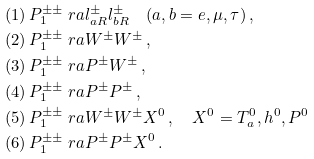<formula> <loc_0><loc_0><loc_500><loc_500>( 1 ) \, P _ { 1 } ^ { \pm \pm } & \ r a l _ { a R } ^ { \pm } l _ { b R } ^ { \pm } \quad ( a , b = e , \mu , \tau ) \, , \\ ( 2 ) \, P _ { 1 } ^ { \pm \pm } & \ r a W ^ { \pm } W ^ { \pm } \, , \\ ( 3 ) \, P _ { 1 } ^ { \pm \pm } & \ r a P ^ { \pm } W ^ { \pm } \, , \\ ( 4 ) \, P _ { 1 } ^ { \pm \pm } & \ r a P ^ { \pm } P ^ { \pm } \, , \\ ( 5 ) \, P _ { 1 } ^ { \pm \pm } & \ r a W ^ { \pm } W ^ { \pm } X ^ { 0 } \, , \quad X ^ { 0 } = T ^ { 0 } _ { a } , h ^ { 0 } , P ^ { 0 } \\ ( 6 ) \, P _ { 1 } ^ { \pm \pm } & \ r a P ^ { \pm } P ^ { \pm } X ^ { 0 } \, .</formula> 